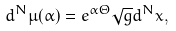Convert formula to latex. <formula><loc_0><loc_0><loc_500><loc_500>d ^ { N } \mu ( \alpha ) = e ^ { \alpha \Theta } \sqrt { g } d ^ { N } x ,</formula> 